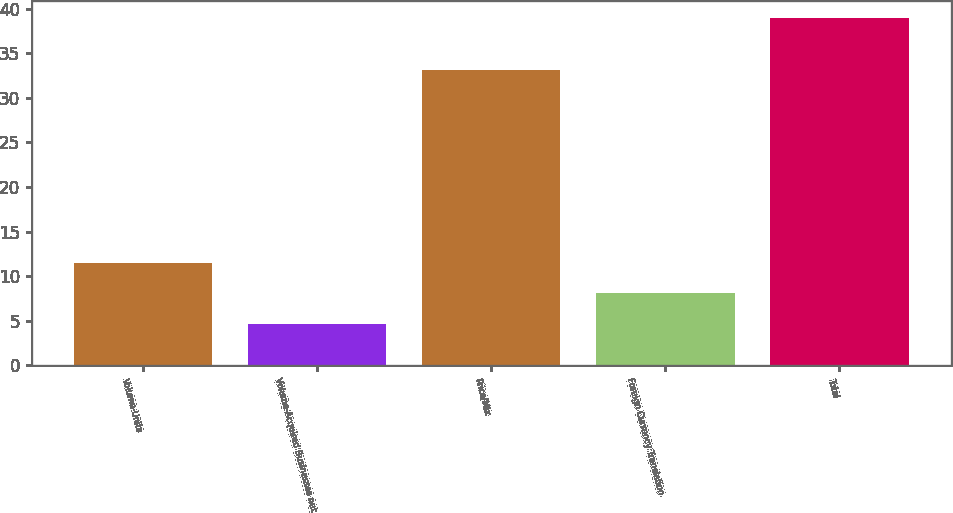<chart> <loc_0><loc_0><loc_500><loc_500><bar_chart><fcel>Volume-Units<fcel>Volume-Acquired Businesses net<fcel>Price/Mix<fcel>Foreign Currency Translation<fcel>Total<nl><fcel>11.54<fcel>4.7<fcel>33.1<fcel>8.12<fcel>38.9<nl></chart> 